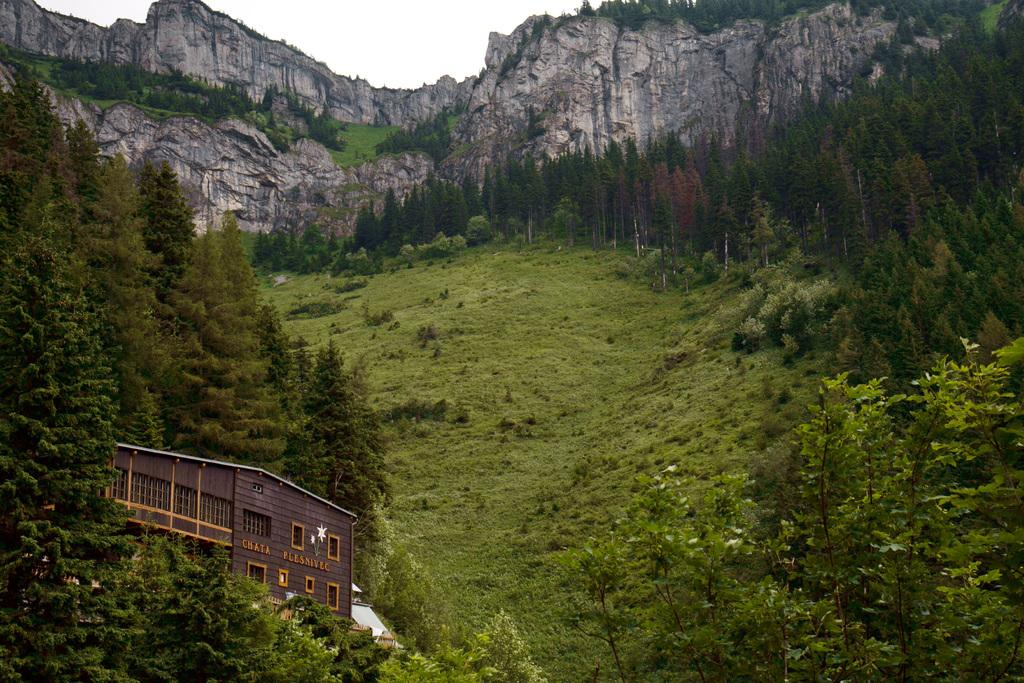What type of structure is present in the image? There is a building in the image. What other natural elements can be seen in the image? There are trees and hills in the image. What is visible behind the hills in the image? The sky is visible behind the hills. Where are the kitties playing on the hills in the image? There are no kitties present in the image. 